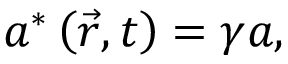<formula> <loc_0><loc_0><loc_500><loc_500>a ^ { \ast } \left ( \vec { r } , t \right ) = \gamma a ,</formula> 